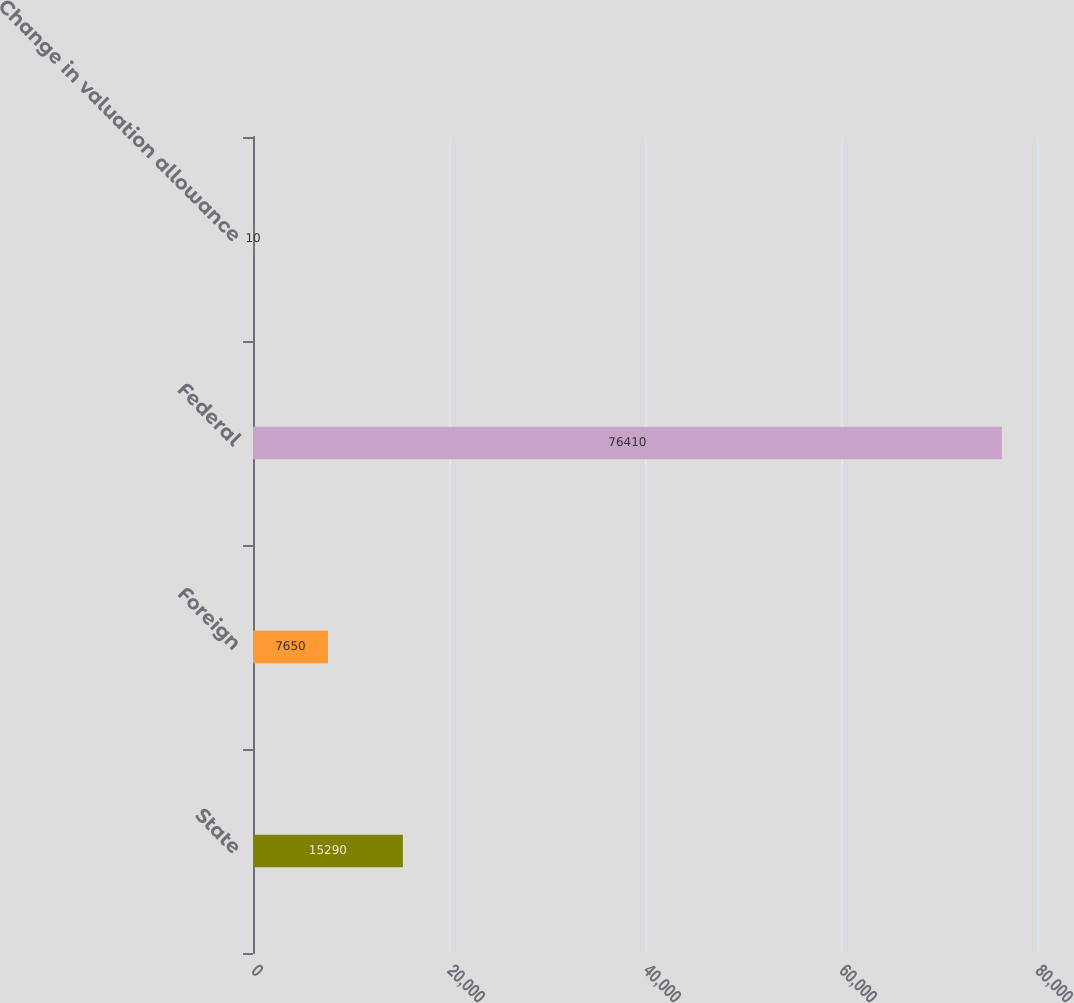Convert chart to OTSL. <chart><loc_0><loc_0><loc_500><loc_500><bar_chart><fcel>State<fcel>Foreign<fcel>Federal<fcel>Change in valuation allowance<nl><fcel>15290<fcel>7650<fcel>76410<fcel>10<nl></chart> 